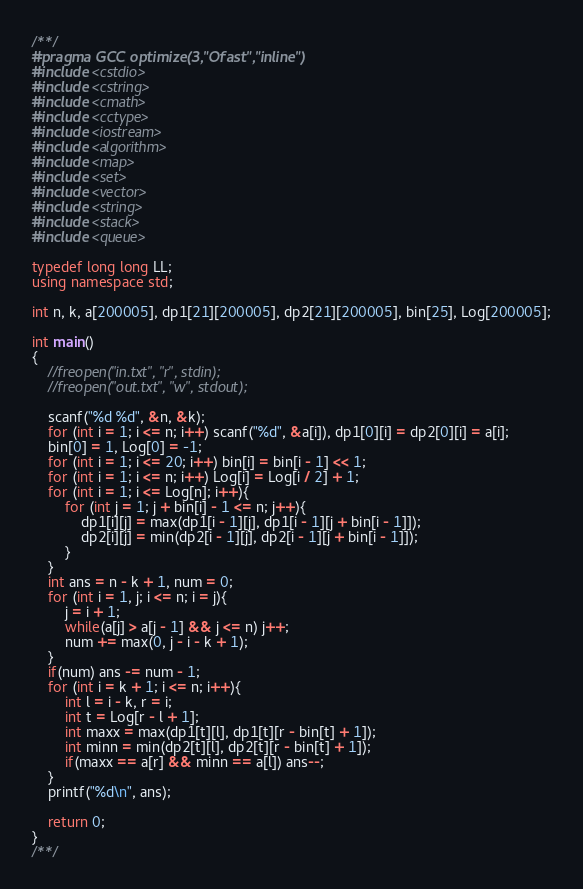Convert code to text. <code><loc_0><loc_0><loc_500><loc_500><_C++_>/**/
#pragma GCC optimize(3,"Ofast","inline")
#include <cstdio>
#include <cstring>
#include <cmath>
#include <cctype>
#include <iostream>
#include <algorithm>
#include <map>
#include <set>
#include <vector>
#include <string>
#include <stack>
#include <queue>

typedef long long LL;
using namespace std;

int n, k, a[200005], dp1[21][200005], dp2[21][200005], bin[25], Log[200005];

int main()
{
	//freopen("in.txt", "r", stdin);
	//freopen("out.txt", "w", stdout);

	scanf("%d %d", &n, &k);
	for (int i = 1; i <= n; i++) scanf("%d", &a[i]), dp1[0][i] = dp2[0][i] = a[i];
	bin[0] = 1, Log[0] = -1;
	for (int i = 1; i <= 20; i++) bin[i] = bin[i - 1] << 1;
	for (int i = 1; i <= n; i++) Log[i] = Log[i / 2] + 1;
	for (int i = 1; i <= Log[n]; i++){
		for (int j = 1; j + bin[i] - 1 <= n; j++){
			dp1[i][j] = max(dp1[i - 1][j], dp1[i - 1][j + bin[i - 1]]);
			dp2[i][j] = min(dp2[i - 1][j], dp2[i - 1][j + bin[i - 1]]);
		}
	}
	int ans = n - k + 1, num = 0;
	for (int i = 1, j; i <= n; i = j){
		j = i + 1;
		while(a[j] > a[j - 1] && j <= n) j++;
		num += max(0, j - i - k + 1);
	}
	if(num) ans -= num - 1;
	for (int i = k + 1; i <= n; i++){
		int l = i - k, r = i;
		int t = Log[r - l + 1];
		int maxx = max(dp1[t][l], dp1[t][r - bin[t] + 1]);
		int minn = min(dp2[t][l], dp2[t][r - bin[t] + 1]);
		if(maxx == a[r] && minn == a[l]) ans--;
	}
	printf("%d\n", ans);

	return 0;
}
/**/</code> 